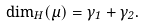Convert formula to latex. <formula><loc_0><loc_0><loc_500><loc_500>\dim _ { H } ( \mu ) = \gamma _ { 1 } + \gamma _ { 2 } .</formula> 